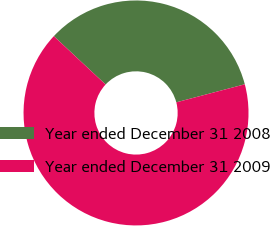Convert chart. <chart><loc_0><loc_0><loc_500><loc_500><pie_chart><fcel>Year ended December 31 2008<fcel>Year ended December 31 2009<nl><fcel>33.94%<fcel>66.06%<nl></chart> 